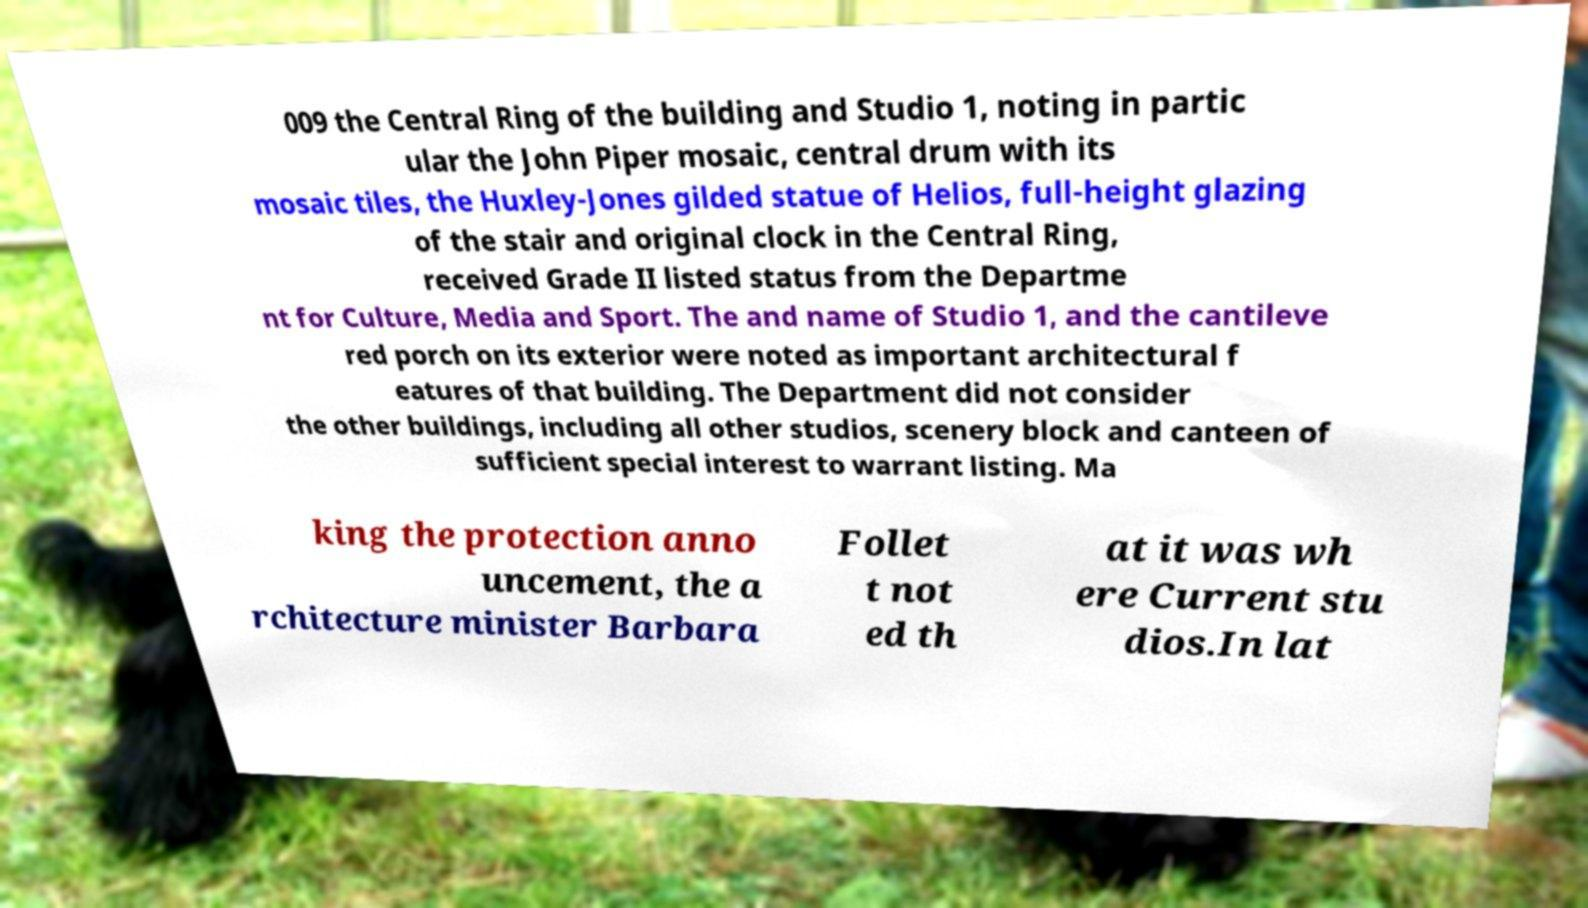There's text embedded in this image that I need extracted. Can you transcribe it verbatim? 009 the Central Ring of the building and Studio 1, noting in partic ular the John Piper mosaic, central drum with its mosaic tiles, the Huxley-Jones gilded statue of Helios, full-height glazing of the stair and original clock in the Central Ring, received Grade II listed status from the Departme nt for Culture, Media and Sport. The and name of Studio 1, and the cantileve red porch on its exterior were noted as important architectural f eatures of that building. The Department did not consider the other buildings, including all other studios, scenery block and canteen of sufficient special interest to warrant listing. Ma king the protection anno uncement, the a rchitecture minister Barbara Follet t not ed th at it was wh ere Current stu dios.In lat 